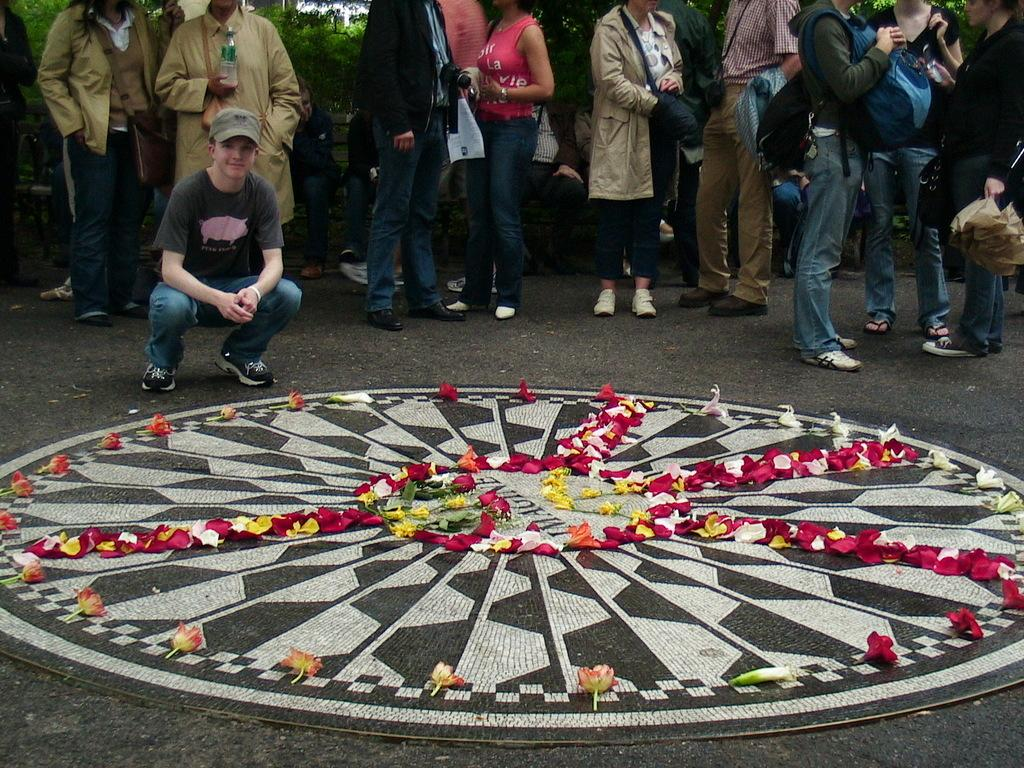What are the people in the image doing? The people in the image are standing. Can you describe the position of one of the people in the image? There is a person sitting in a squat position. What type of design can be seen in the image? There are flowers on a design in the image. What can be seen in the background of the image? There are trees visible in the background of the image. How does the woman in the image control the trouble? There is no woman present in the image, and no mention of trouble or control. 